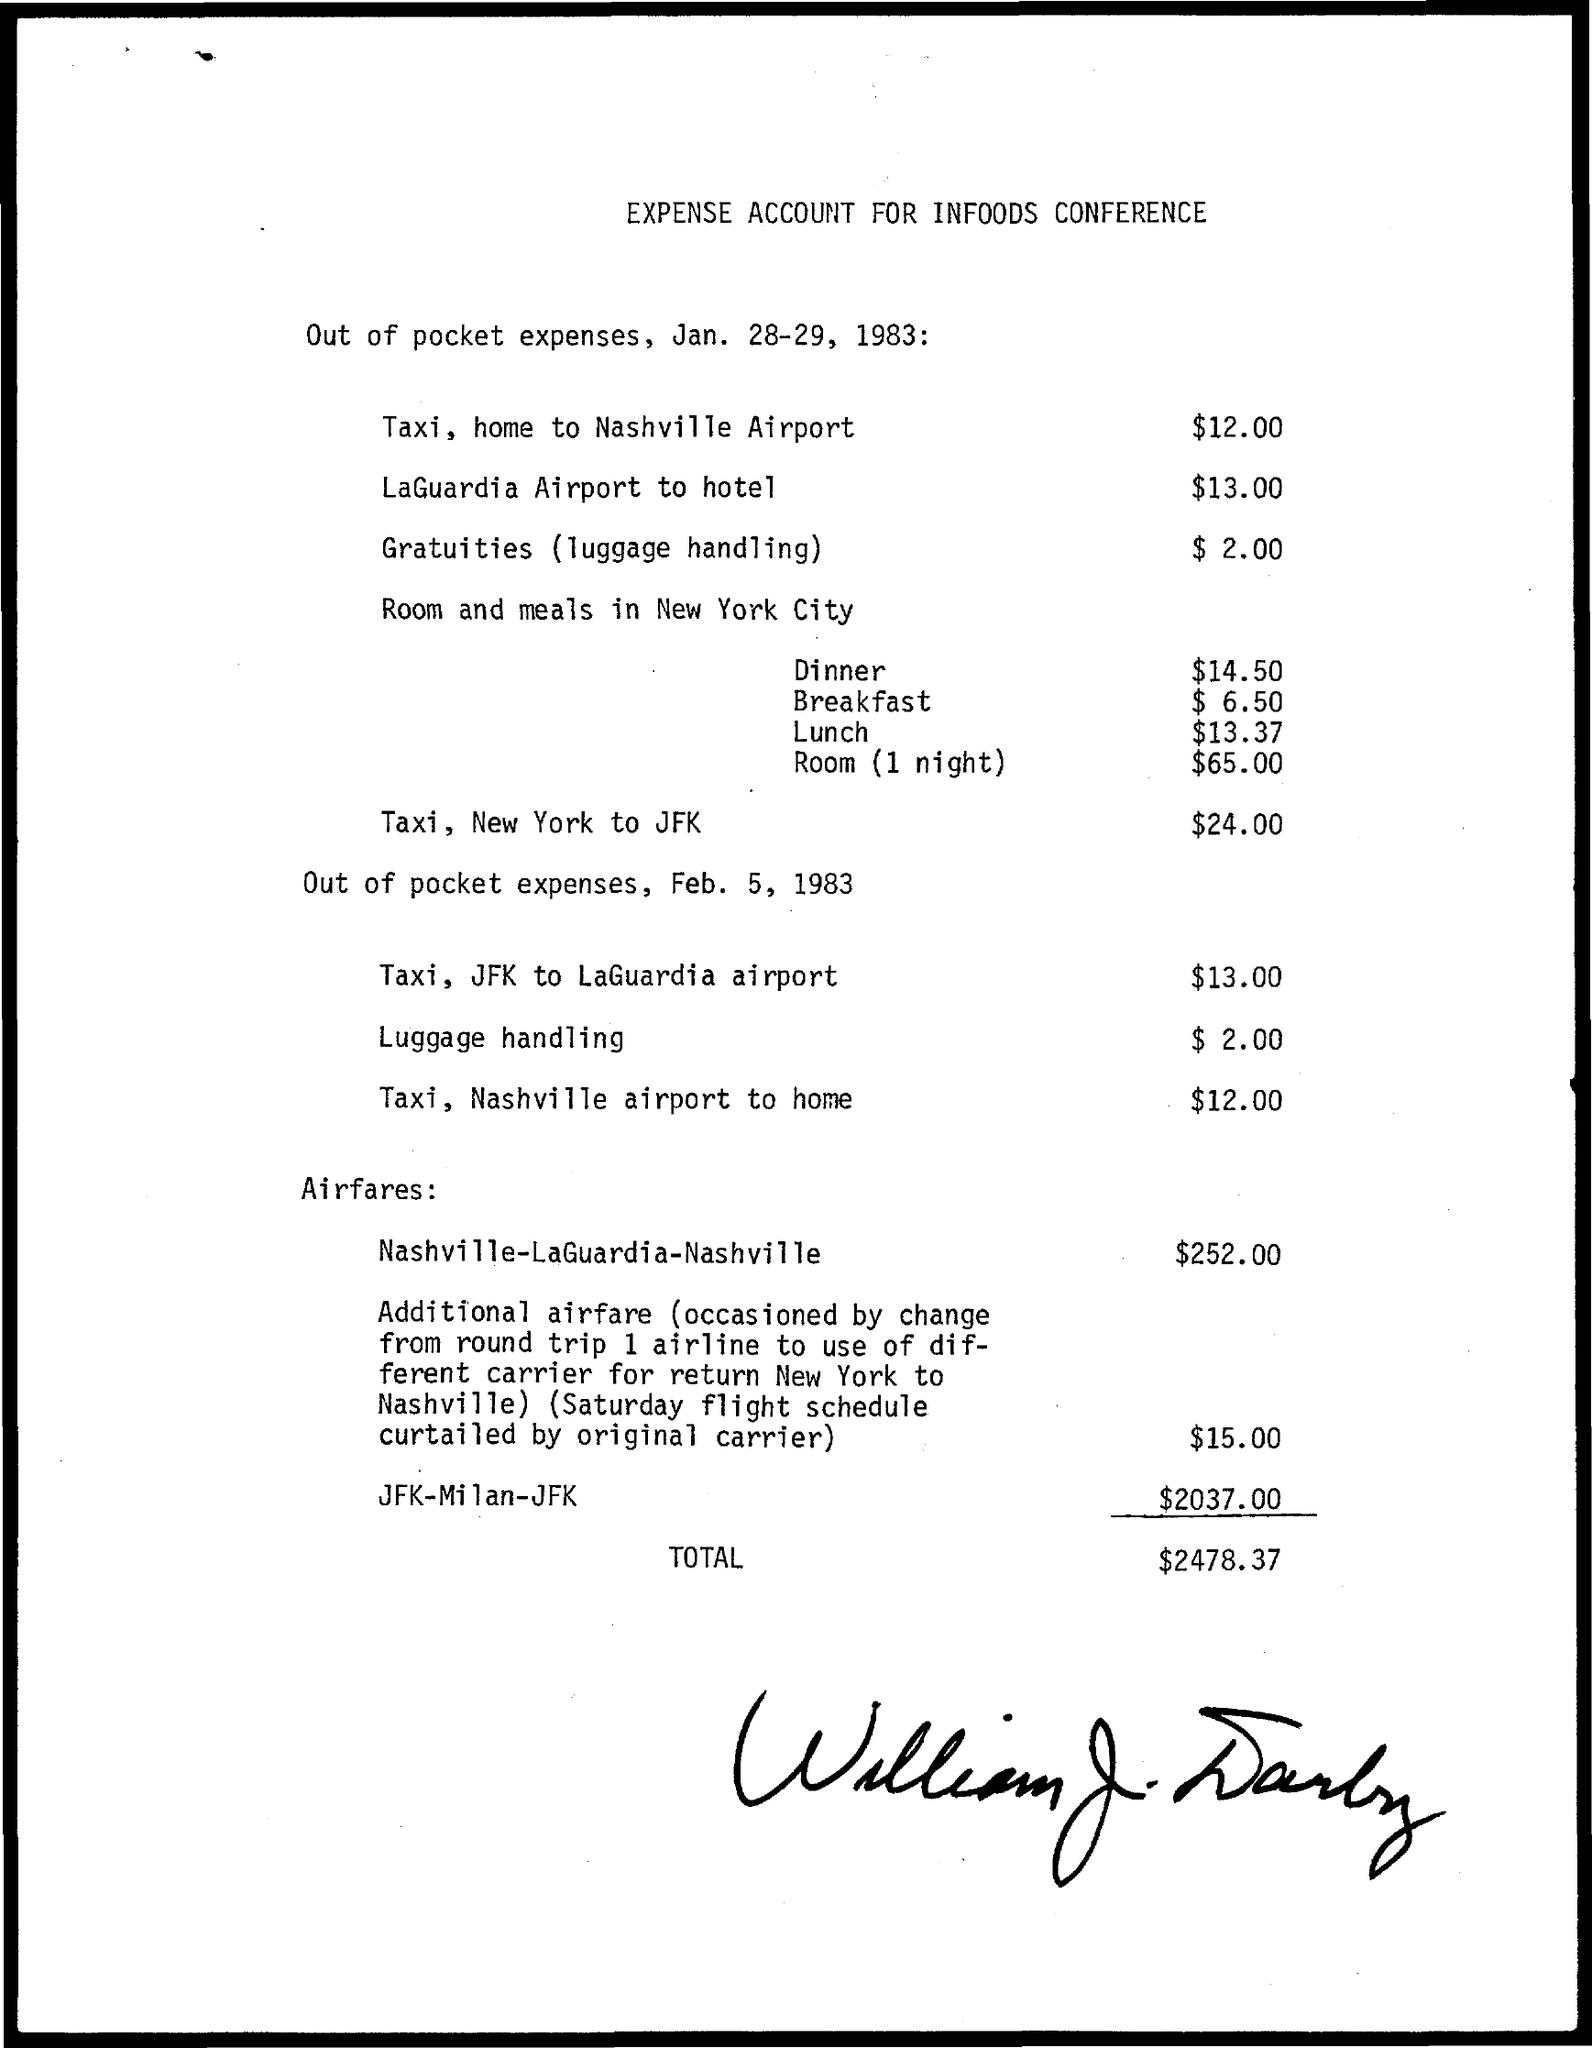What is the Title of the document?
Offer a terse response. Expense Account for Infoods Conference. What is the expense for Taxi, home to Nashville Airport?
Your answer should be compact. $12.00. What is the expense for LaGuardia Airport to hotel?
Keep it short and to the point. $13.00. What is the expense for Gratuities (luggage handling)?
Offer a terse response. $2.00. What is the expense for Dinner?
Provide a succinct answer. $14.50. What is the expense for Breakfast?
Provide a short and direct response. $6.50. What is the expense for Lunch?
Give a very brief answer. $13.37. What is the expense for Room(1 night)?
Make the answer very short. $65.00. What is the expense for Taxi, JFK to LaGuardia Airport?
Ensure brevity in your answer.  $13.00. What is the Total?
Your response must be concise. $2478.37. 